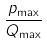<formula> <loc_0><loc_0><loc_500><loc_500>\frac { p _ { \max } } { Q _ { \max } }</formula> 